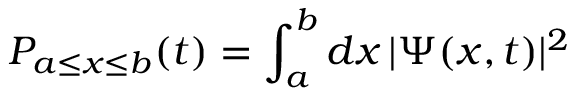Convert formula to latex. <formula><loc_0><loc_0><loc_500><loc_500>P _ { a \leq x \leq b } ( t ) = \int _ { a } ^ { b } d x \, | \Psi ( x , t ) | ^ { 2 }</formula> 